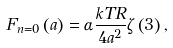Convert formula to latex. <formula><loc_0><loc_0><loc_500><loc_500>F _ { n = 0 } \left ( a \right ) = \alpha \frac { k T R } { 4 a ^ { 2 } } \zeta \left ( 3 \right ) ,</formula> 